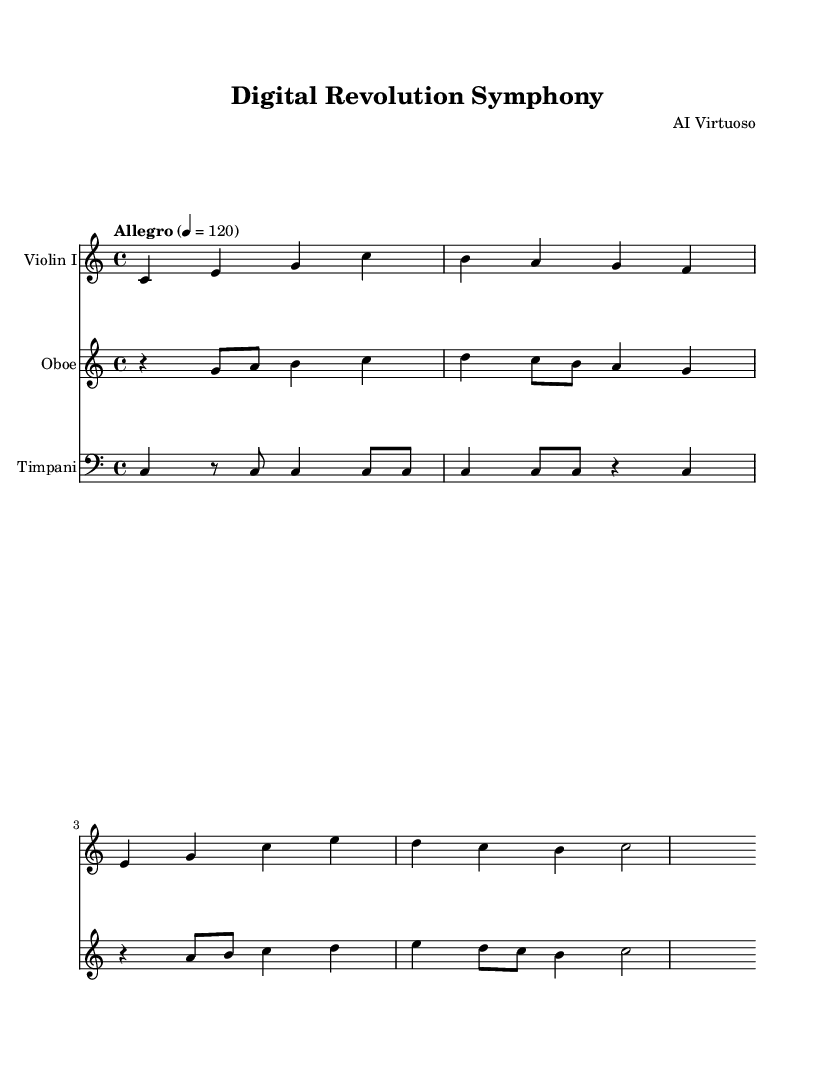What is the key signature of this music? The key signature is C major, which has no sharps or flats, as indicated at the beginning of the score.
Answer: C major What is the time signature of this music? The time signature is 4/4, which is marked at the beginning of the score, indicating four beats per measure.
Answer: 4/4 What is the tempo marking of this piece? The tempo marking "Allegro" indicates a fast pace, specifically quarter note equals 120 beats per minute, presented at the beginning of the score.
Answer: Allegro How many measures are in the Violin I part? The Violin I part consists of four measures, as observed in the notation where there are four distinct groupings of notes before the repeat or end.
Answer: 4 Which instruments are included in this composition? The score shows the instruments Violin I, Oboe, and Timpani, identified by the instrument names above each staff.
Answer: Violin I, Oboe, Timpani What is the rhythmic pattern of the Timpani part? The Timpani part features a combination of whole notes and a rest, initially starting with a quarter note and alternating with eighth notes. This creates a varied rhythmic feel compared to the other instruments.
Answer: Quarter notes and rests How does the Oboe part contribute to the overall texture? The Oboe part complements the strings by providing a melodic line that ascends and descends, creating a harmonizing effect against the violin, indicated by the use of different pitches and rhythms.
Answer: Melodic line 